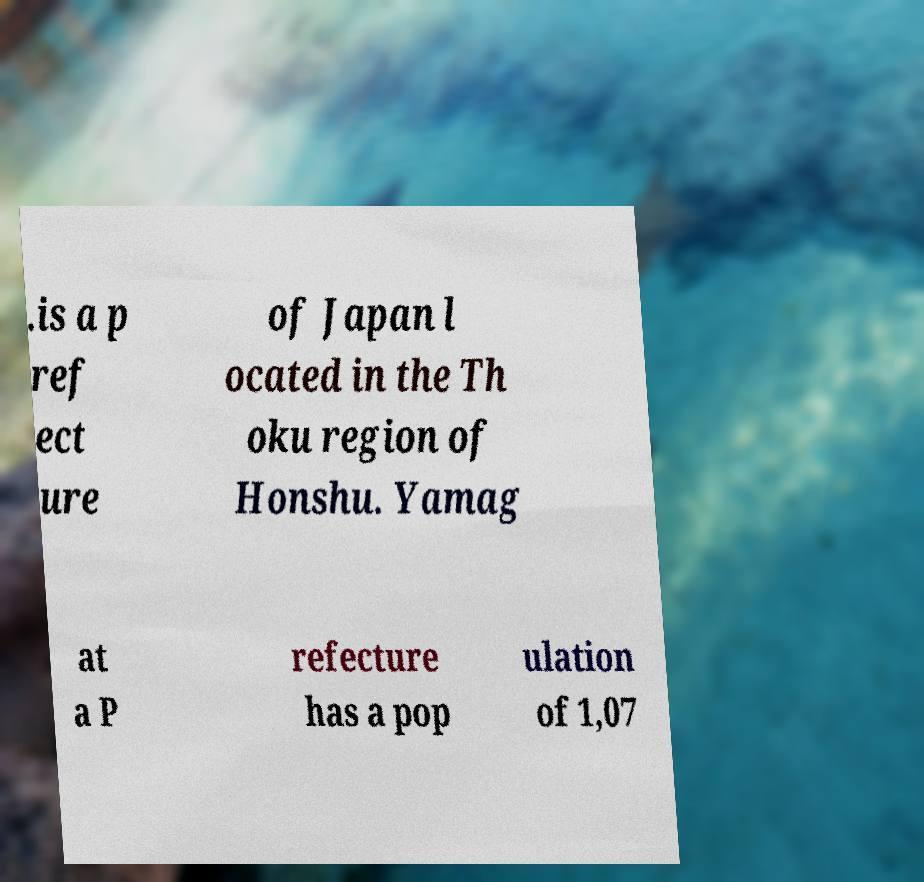For documentation purposes, I need the text within this image transcribed. Could you provide that? .is a p ref ect ure of Japan l ocated in the Th oku region of Honshu. Yamag at a P refecture has a pop ulation of 1,07 